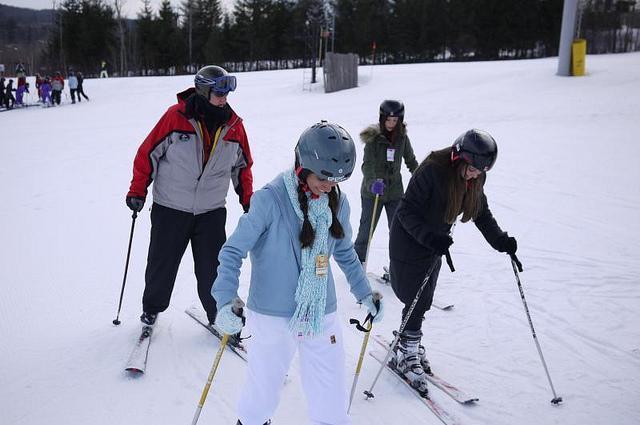What is this group ready to do?
Choose the right answer and clarify with the format: 'Answer: answer
Rationale: rationale.'
Options: Descend, run, ascend, duck. Answer: descend.
Rationale: The group is getting ready to ski. when you ski you ride down a 